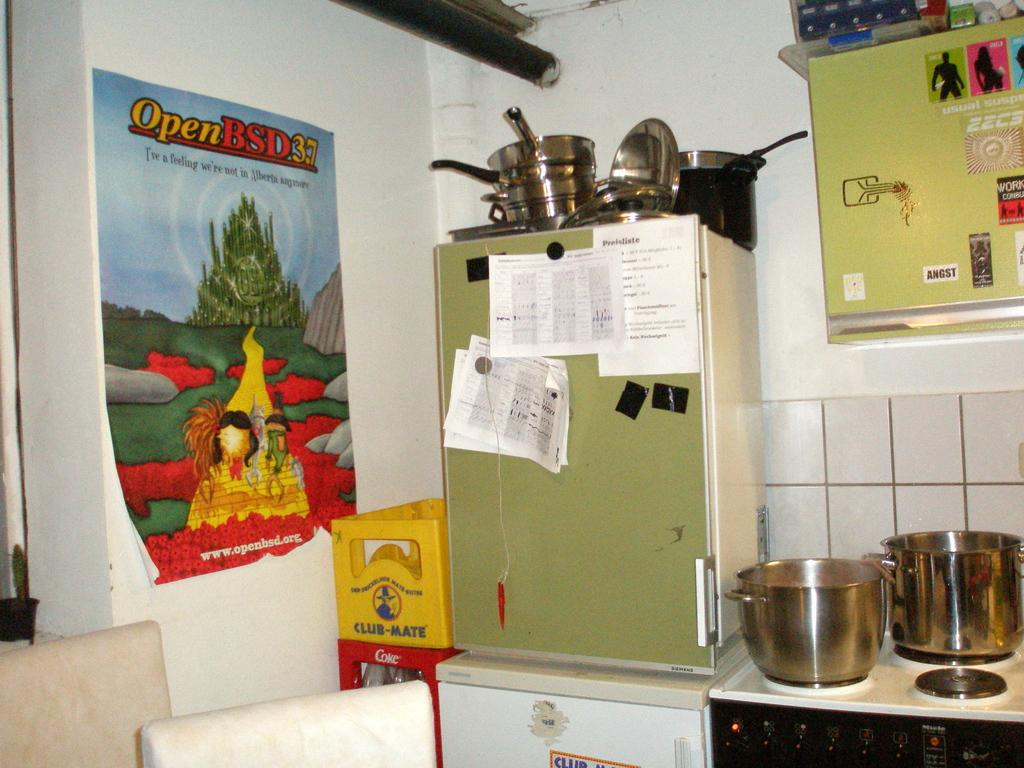<image>
Write a terse but informative summary of the picture. A kitchen with a poster of OpenBSD3.7 on the wall 